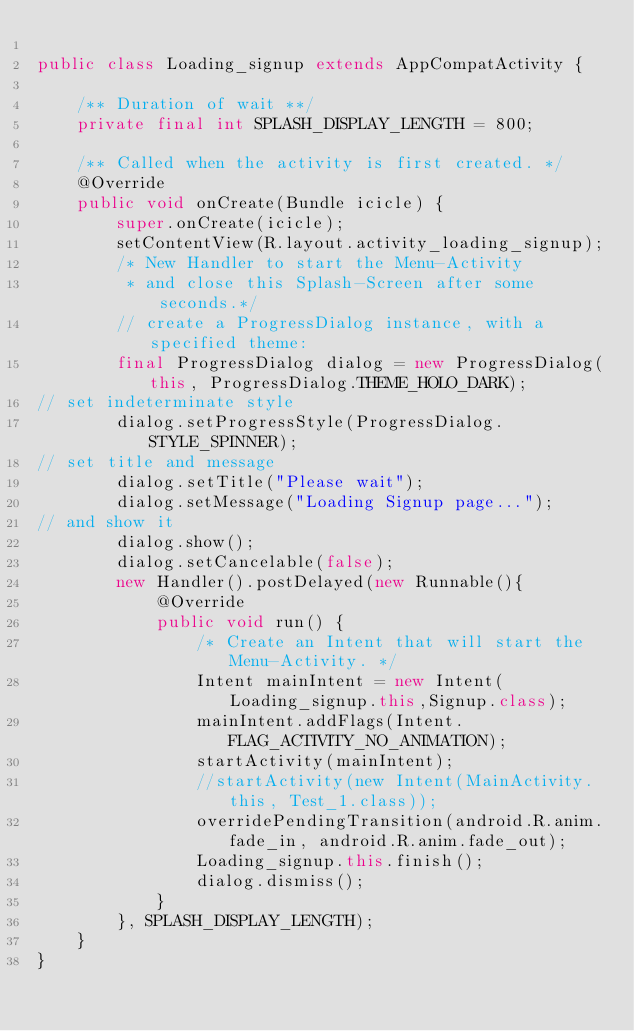Convert code to text. <code><loc_0><loc_0><loc_500><loc_500><_Java_>
public class Loading_signup extends AppCompatActivity {

    /** Duration of wait **/
    private final int SPLASH_DISPLAY_LENGTH = 800;

    /** Called when the activity is first created. */
    @Override
    public void onCreate(Bundle icicle) {
        super.onCreate(icicle);
        setContentView(R.layout.activity_loading_signup);
        /* New Handler to start the Menu-Activity
         * and close this Splash-Screen after some seconds.*/
        // create a ProgressDialog instance, with a specified theme:
        final ProgressDialog dialog = new ProgressDialog(this, ProgressDialog.THEME_HOLO_DARK);
// set indeterminate style
        dialog.setProgressStyle(ProgressDialog.STYLE_SPINNER);
// set title and message
        dialog.setTitle("Please wait");
        dialog.setMessage("Loading Signup page...");
// and show it
        dialog.show();
        dialog.setCancelable(false);
        new Handler().postDelayed(new Runnable(){
            @Override
            public void run() {
                /* Create an Intent that will start the Menu-Activity. */
                Intent mainIntent = new Intent(Loading_signup.this,Signup.class);
                mainIntent.addFlags(Intent.FLAG_ACTIVITY_NO_ANIMATION);
                startActivity(mainIntent);
                //startActivity(new Intent(MainActivity.this, Test_1.class));
                overridePendingTransition(android.R.anim.fade_in, android.R.anim.fade_out);
                Loading_signup.this.finish();
                dialog.dismiss();
            }
        }, SPLASH_DISPLAY_LENGTH);
    }
}
</code> 